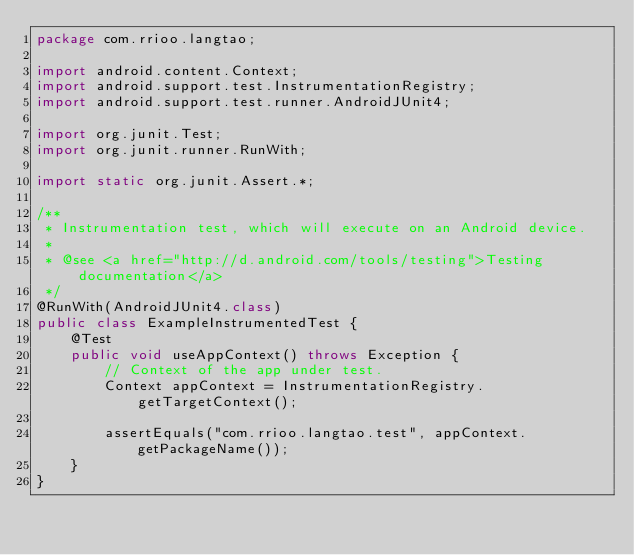<code> <loc_0><loc_0><loc_500><loc_500><_Java_>package com.rrioo.langtao;

import android.content.Context;
import android.support.test.InstrumentationRegistry;
import android.support.test.runner.AndroidJUnit4;

import org.junit.Test;
import org.junit.runner.RunWith;

import static org.junit.Assert.*;

/**
 * Instrumentation test, which will execute on an Android device.
 *
 * @see <a href="http://d.android.com/tools/testing">Testing documentation</a>
 */
@RunWith(AndroidJUnit4.class)
public class ExampleInstrumentedTest {
    @Test
    public void useAppContext() throws Exception {
        // Context of the app under test.
        Context appContext = InstrumentationRegistry.getTargetContext();

        assertEquals("com.rrioo.langtao.test", appContext.getPackageName());
    }
}
</code> 